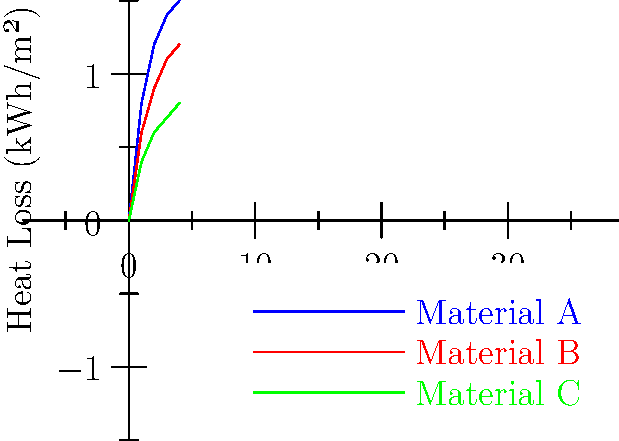Based on the heat loss data for three insulation materials shown in the graph, which material would you recommend for implementation in energy-efficient building design, and what potential public health benefits could result from its widespread adoption? To answer this question, we need to analyze the graph and consider the public health implications:

1. Interpret the graph:
   - The x-axis represents time in hours, and the y-axis represents heat loss in kWh/m².
   - Three materials (A, B, and C) are compared over a 4-hour period.
   - Lower heat loss indicates better insulation performance.

2. Compare the materials:
   - Material A (blue line) shows the highest heat loss.
   - Material B (red line) shows moderate heat loss.
   - Material C (green line) shows the lowest heat loss.

3. Identify the best-performing material:
   - Material C consistently demonstrates the lowest heat loss over time.
   - After 4 hours, Material C loses about 0.8 kWh/m², compared to 1.2 kWh/m² for B and 1.5 kWh/m² for A.

4. Consider energy efficiency:
   - Lower heat loss translates to better energy efficiency.
   - Buildings using Material C would require less energy for heating and cooling.

5. Public health benefits of widespread adoption:
   a) Reduced energy consumption:
      - Lower greenhouse gas emissions from power plants.
      - Improved air quality, reducing respiratory issues.
   b) Cost savings:
      - Lower energy bills, allowing more resources for other health-related expenses.
   c) Improved indoor comfort:
      - Better temperature regulation, reducing heat-related illnesses.
   d) Noise reduction:
      - Better insulation often correlates with noise reduction, improving mental health.
   e) Reduced energy poverty:
      - More affordable heating/cooling for low-income households.

6. Policy relevance:
   - Incentives for using high-performance insulation in new constructions and retrofits.
   - Building codes that mandate minimum insulation standards.
   - Public education programs on the benefits of energy-efficient housing.
Answer: Material C; potential benefits include reduced emissions, improved air quality, cost savings, better indoor comfort, and reduced energy poverty. 